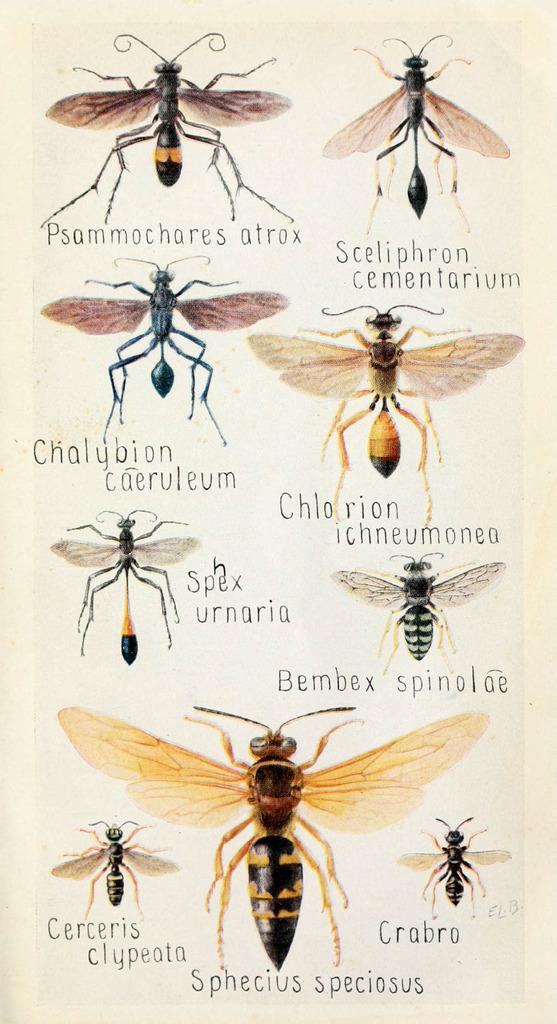What type of visual is the image? The image is a poster. What is the main subject of the poster? The poster contains pictures of different types of insects. Are the insects identified on the poster? Yes, the names of the insects are present on the poster. What color is the pocket on the poster? There is no pocket present on the poster. How is the poster divided into sections? The poster is not divided into sections; it contains pictures and names of insects without any specific divisions. 